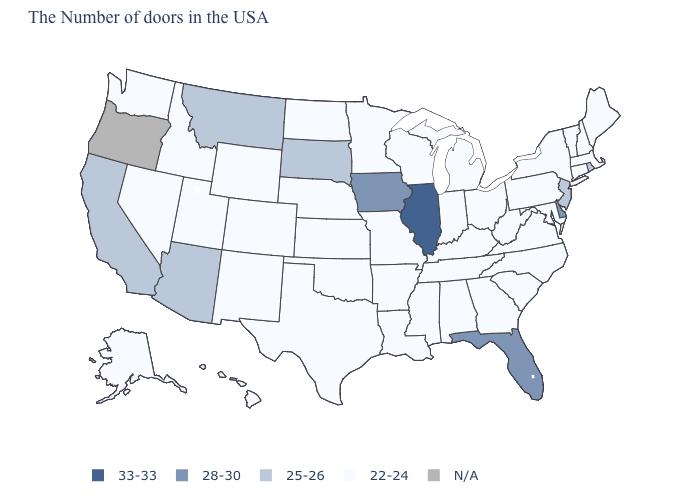Which states hav the highest value in the MidWest?
Short answer required. Illinois. What is the lowest value in the USA?
Be succinct. 22-24. Among the states that border Maryland , which have the lowest value?
Short answer required. Pennsylvania, Virginia, West Virginia. What is the value of North Dakota?
Concise answer only. 22-24. Which states have the highest value in the USA?
Keep it brief. Illinois. How many symbols are there in the legend?
Write a very short answer. 5. What is the value of Delaware?
Keep it brief. 28-30. What is the highest value in the USA?
Answer briefly. 33-33. How many symbols are there in the legend?
Quick response, please. 5. What is the value of California?
Concise answer only. 25-26. What is the lowest value in states that border Tennessee?
Answer briefly. 22-24. Does Alabama have the highest value in the USA?
Concise answer only. No. What is the highest value in the USA?
Write a very short answer. 33-33. How many symbols are there in the legend?
Quick response, please. 5. Is the legend a continuous bar?
Be succinct. No. 